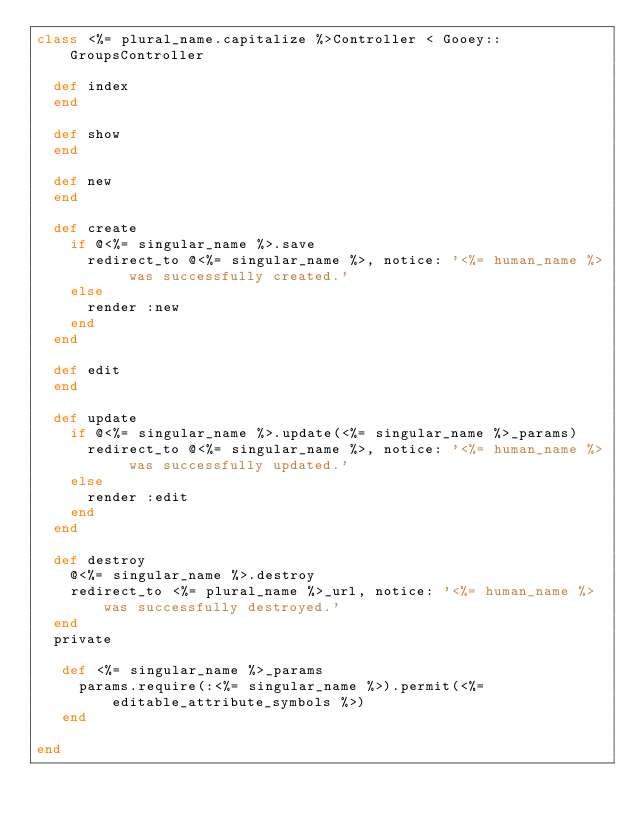<code> <loc_0><loc_0><loc_500><loc_500><_Ruby_>class <%= plural_name.capitalize %>Controller < Gooey::GroupsController

  def index
  end

  def show
  end

  def new
  end

  def create
    if @<%= singular_name %>.save
      redirect_to @<%= singular_name %>, notice: '<%= human_name %> was successfully created.'
    else
      render :new
    end
  end

  def edit
  end

  def update
    if @<%= singular_name %>.update(<%= singular_name %>_params)
      redirect_to @<%= singular_name %>, notice: '<%= human_name %> was successfully updated.'
    else
      render :edit
    end
  end

  def destroy
    @<%= singular_name %>.destroy
    redirect_to <%= plural_name %>_url, notice: '<%= human_name %> was successfully destroyed.'
  end
  private

   def <%= singular_name %>_params
     params.require(:<%= singular_name %>).permit(<%= editable_attribute_symbols %>)
   end

end
</code> 